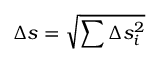Convert formula to latex. <formula><loc_0><loc_0><loc_500><loc_500>\Delta s = \sqrt { \sum \Delta s _ { i } ^ { 2 } }</formula> 